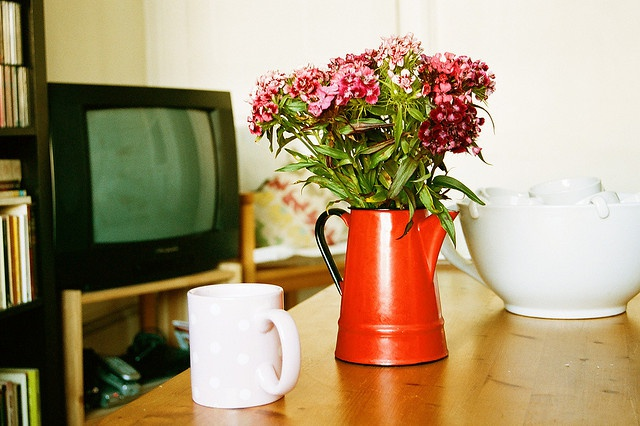Describe the objects in this image and their specific colors. I can see potted plant in black, white, red, and olive tones, dining table in black, tan, and red tones, tv in black, green, and darkgreen tones, cup in black, white, lightgray, and tan tones, and vase in black, red, white, and brown tones in this image. 